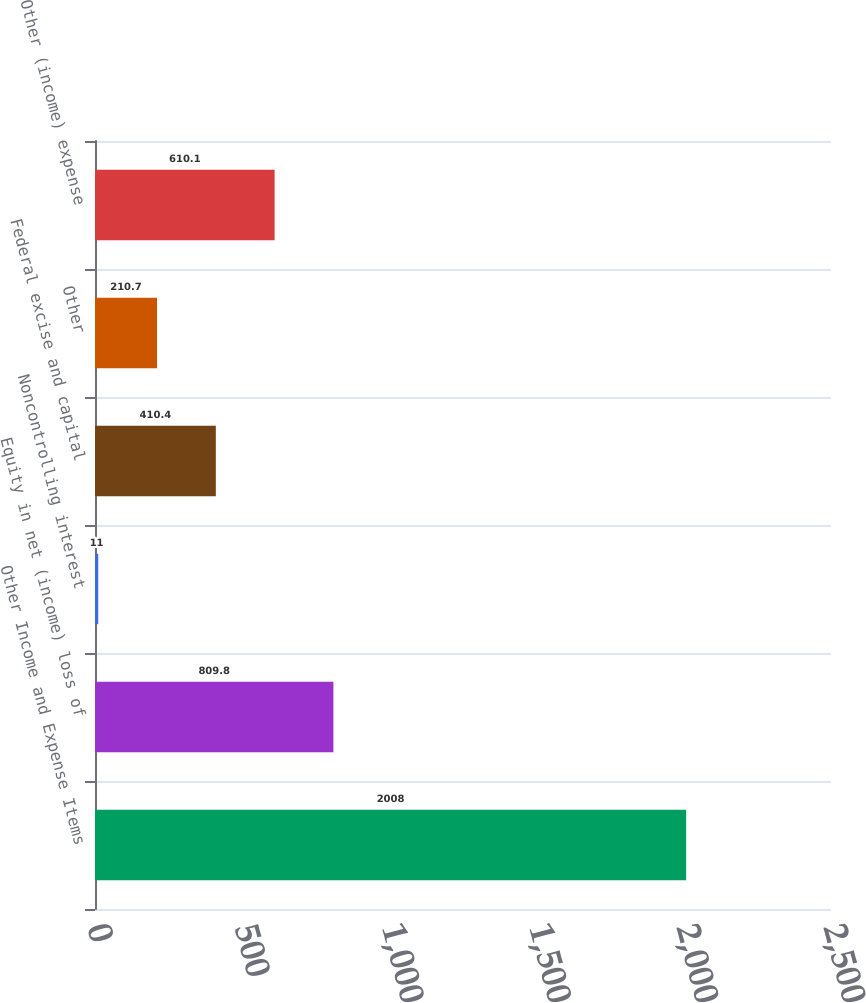Convert chart to OTSL. <chart><loc_0><loc_0><loc_500><loc_500><bar_chart><fcel>Other Income and Expense Items<fcel>Equity in net (income) loss of<fcel>Noncontrolling interest<fcel>Federal excise and capital<fcel>Other<fcel>Other (income) expense<nl><fcel>2008<fcel>809.8<fcel>11<fcel>410.4<fcel>210.7<fcel>610.1<nl></chart> 